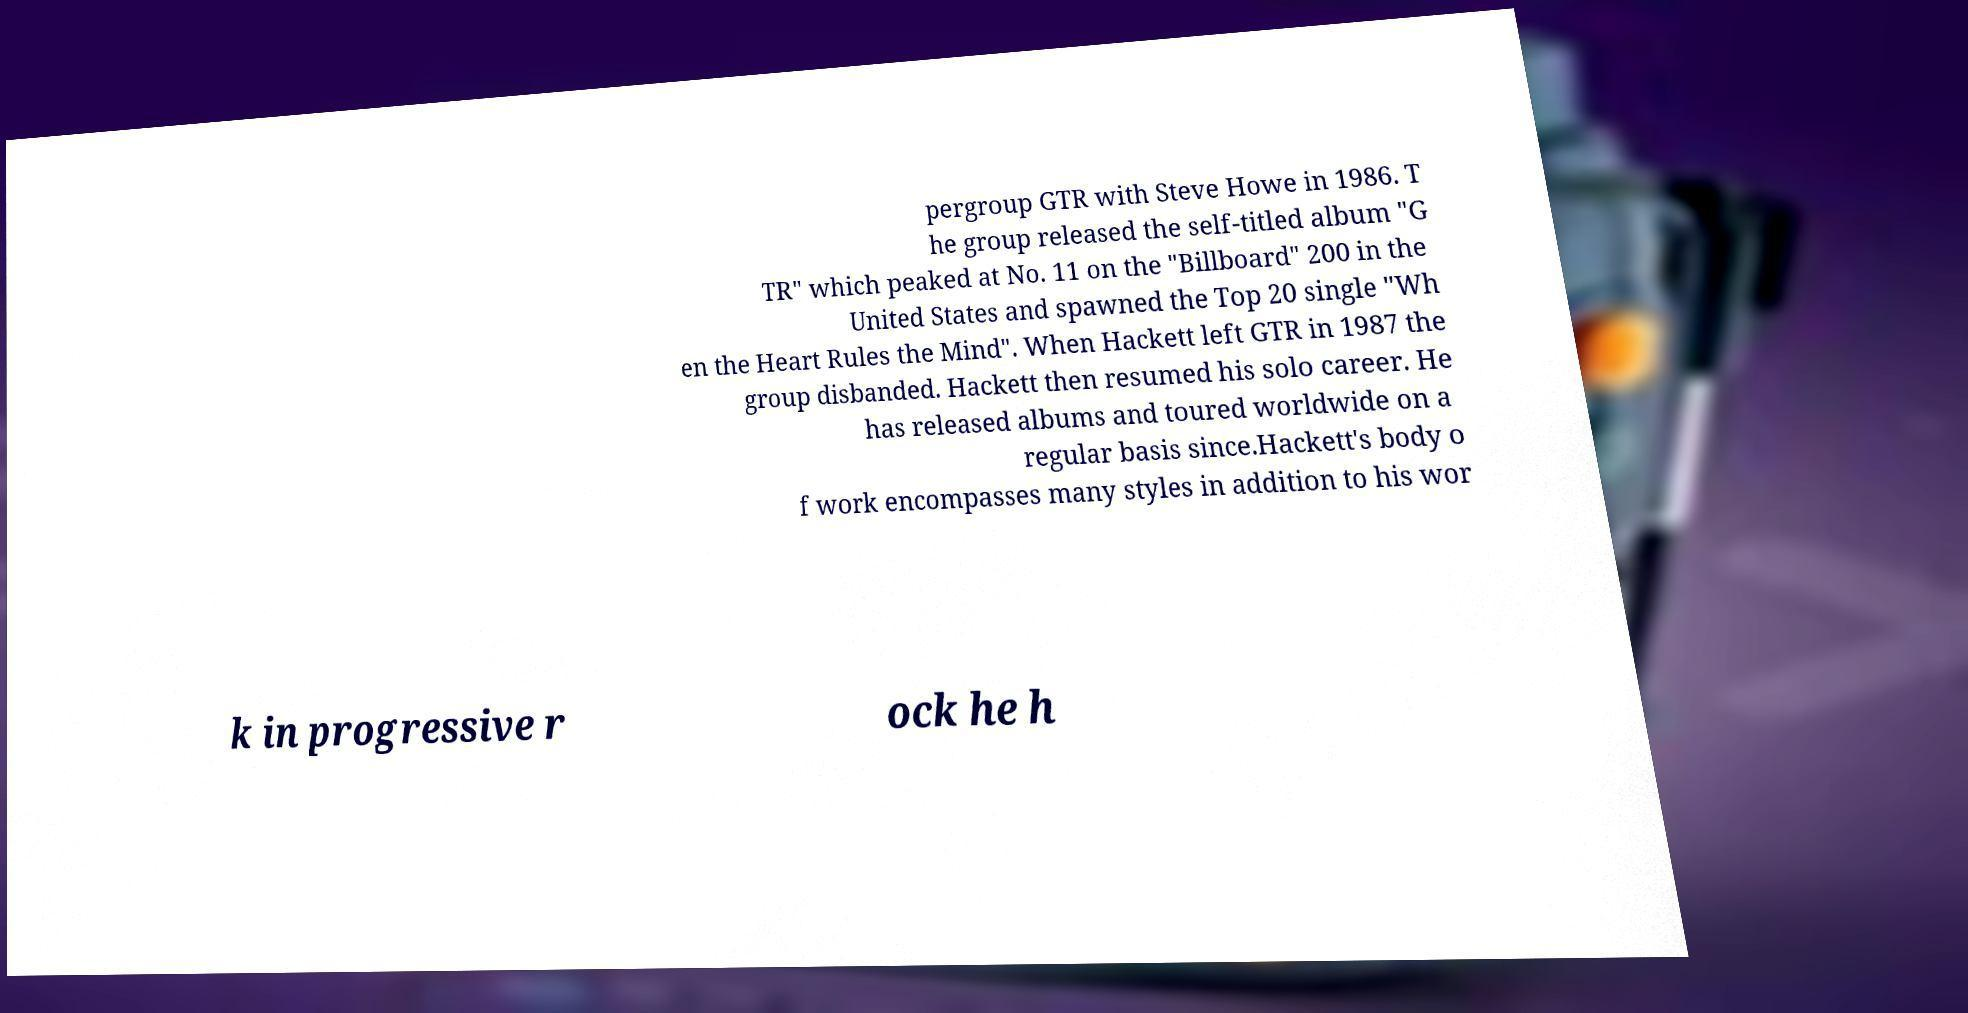Could you assist in decoding the text presented in this image and type it out clearly? pergroup GTR with Steve Howe in 1986. T he group released the self-titled album "G TR" which peaked at No. 11 on the "Billboard" 200 in the United States and spawned the Top 20 single "Wh en the Heart Rules the Mind". When Hackett left GTR in 1987 the group disbanded. Hackett then resumed his solo career. He has released albums and toured worldwide on a regular basis since.Hackett's body o f work encompasses many styles in addition to his wor k in progressive r ock he h 